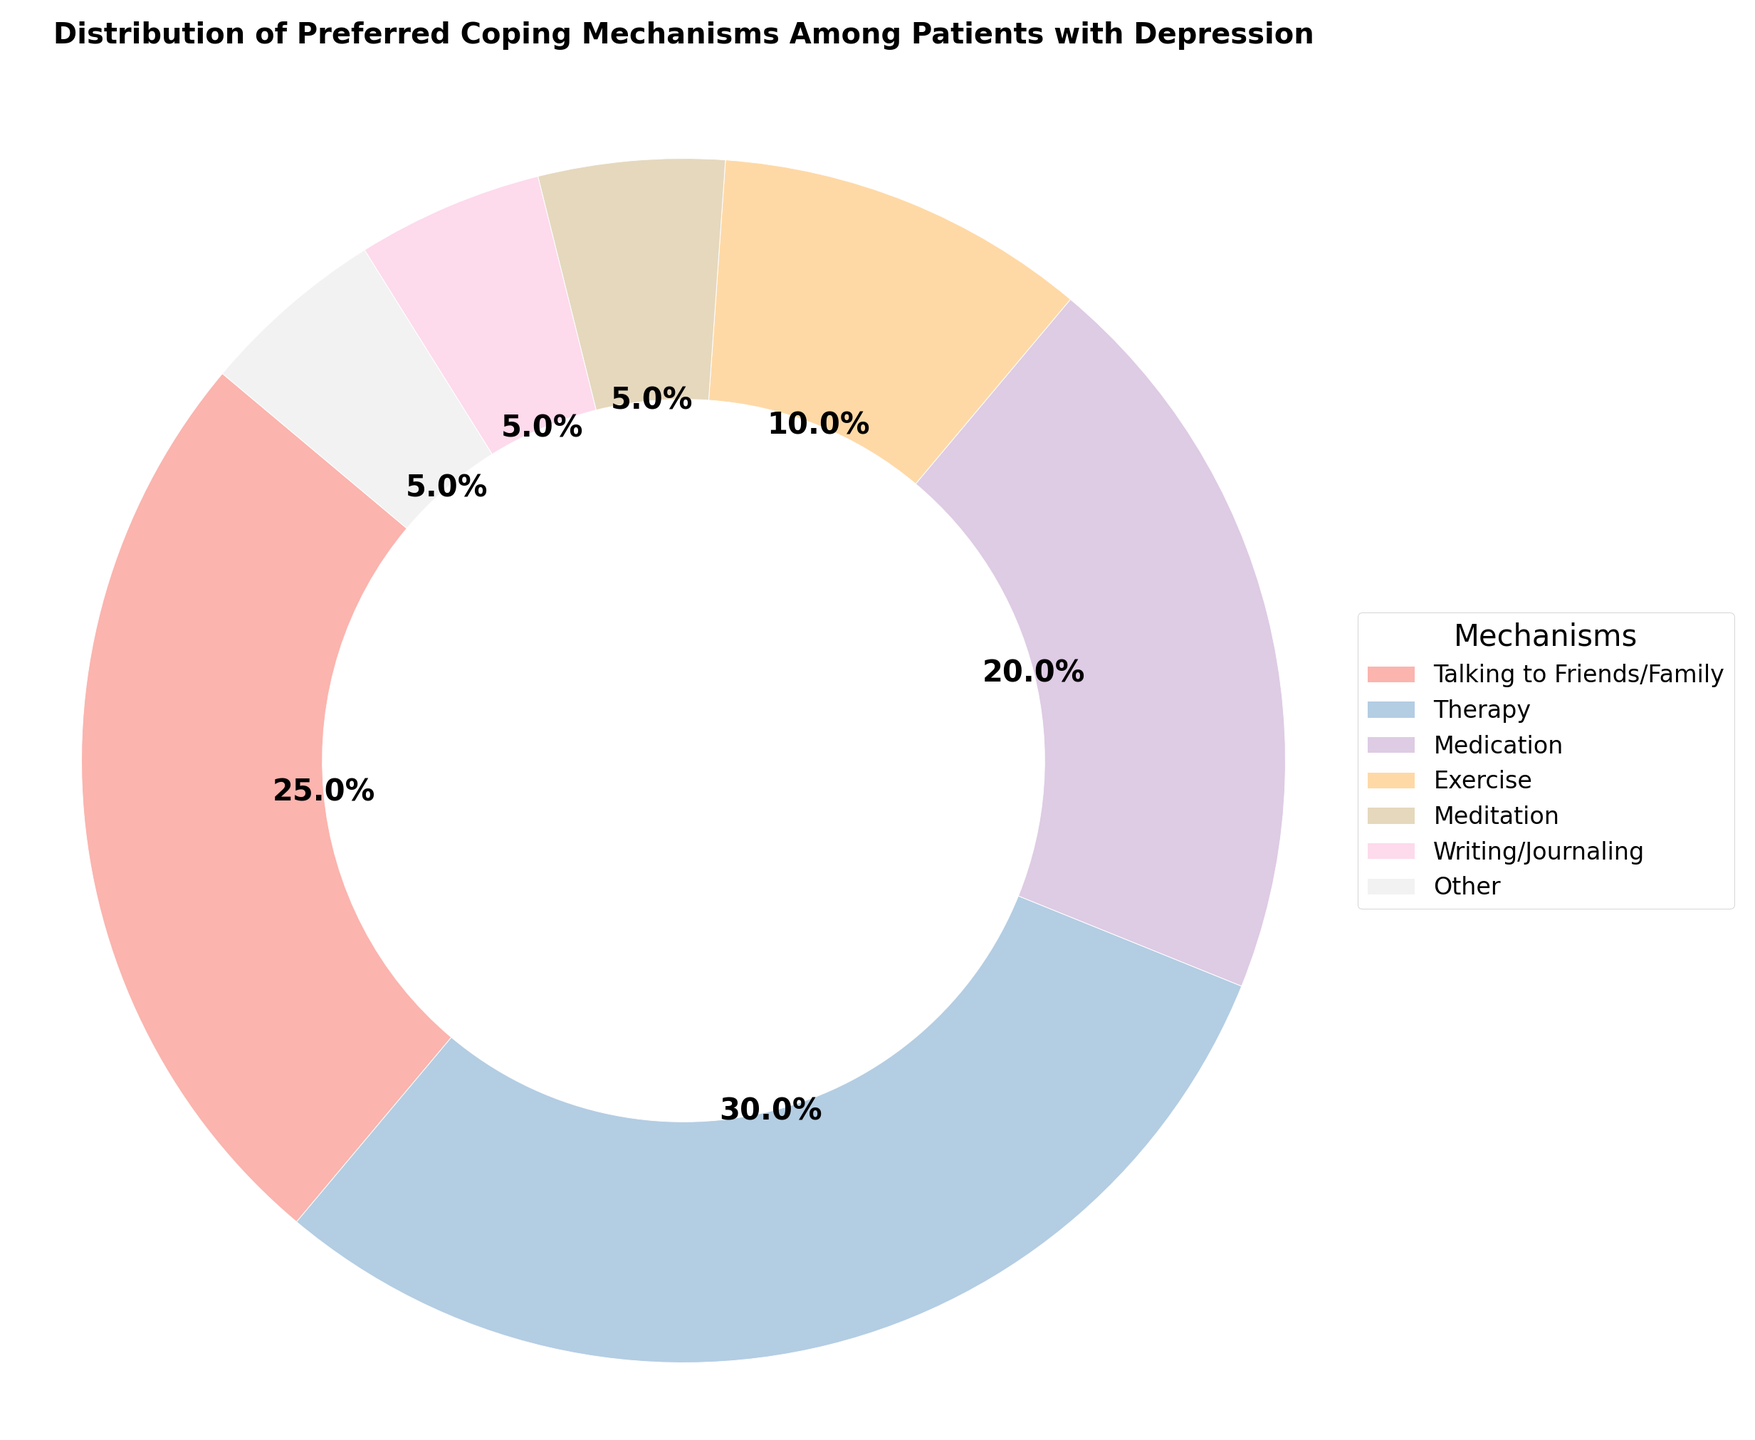What is the most preferred coping mechanism among patients with depression? The pie chart shows the distribution of preferred coping mechanisms among patients with depression. By looking at the segment with the largest percentage, we can see it is "Therapy" with 30%.
Answer: Therapy Which coping mechanism accounts for more, medication or exercise? To determine which coping mechanism accounts for more, compare the percentages of Medication and Exercise. Medication accounts for 20% while Exercise accounts for 10%. Therefore, Medication accounts for more.
Answer: Medication What is the combined percentage of patients who prefer meditation, writing/journaling, and other mechanisms? To find the combined percentage, add the percentages of Meditation, Writing/Journaling, and Other. These are 5%, 5%, and 5% respectively. So, 5 + 5 + 5 = 15%.
Answer: 15% Is talking to friends/family preferred more or less than medication? By comparing the percentages of Talking to Friends/Family (25%) and Medication (20%), we can see that Talking to Friends/Family is preferred more.
Answer: More What percentage of patients prefer either therapy or exercise? To determine what percentage of patients prefer either Therapy or Exercise, sum the percentages of both. Therapy accounts for 30% and Exercise for 10%, so 30 + 10 = 40%.
Answer: 40% Which coping mechanism has the smallest slice in the pie chart? By identifying the smallest segment in the pie chart, we see that Meditation, Writing/Journaling, and Other each have the smallest slice with 5%.
Answer: Meditation, Writing/Journaling, and Other How much more popular is talking to friends/family compared to meditation? To find out how much more popular Talking to Friends/Family is compared to Meditation, subtract the percentage of Meditation (5%) from Talking to Friends/Family (25%). So, 25 - 5 = 20%.
Answer: 20% Is the percentage of patients who prefer medication and exercise together larger than those who prefer therapy? Combine the percentages of Medication and Exercise and compare with Therapy. Medication + Exercise = 20% + 10% = 30%. Therapy alone is 30%. Since 30% is equal to 30%, the percentages are the same.
Answer: Equal Arrange the coping mechanisms from most preferred to least preferred. By arranging the coping mechanisms based on their percentages from highest to lowest, we get: Therapy (30%), Talking to Friends/Family (25%), Medication (20%), Exercise (10%), Meditation/Writing/Journaling/Other (each 5%).
Answer: Therapy, Talking to Friends/Family, Medication, Exercise, Meditation/Writing/Journaling/Other What is the total percentage of patients who prefer non-therapy-based mechanisms? To find the total percentage for non-therapy mechanisms, sum the percentages of all other mechanisms. These are Talking to Friends/Family (25%), Medication (20%), Exercise (10%), Meditation (5%), Writing/Journaling (5%), Other (5%). So, 25 + 20 + 10 + 5 + 5 + 5 = 70%.
Answer: 70% 